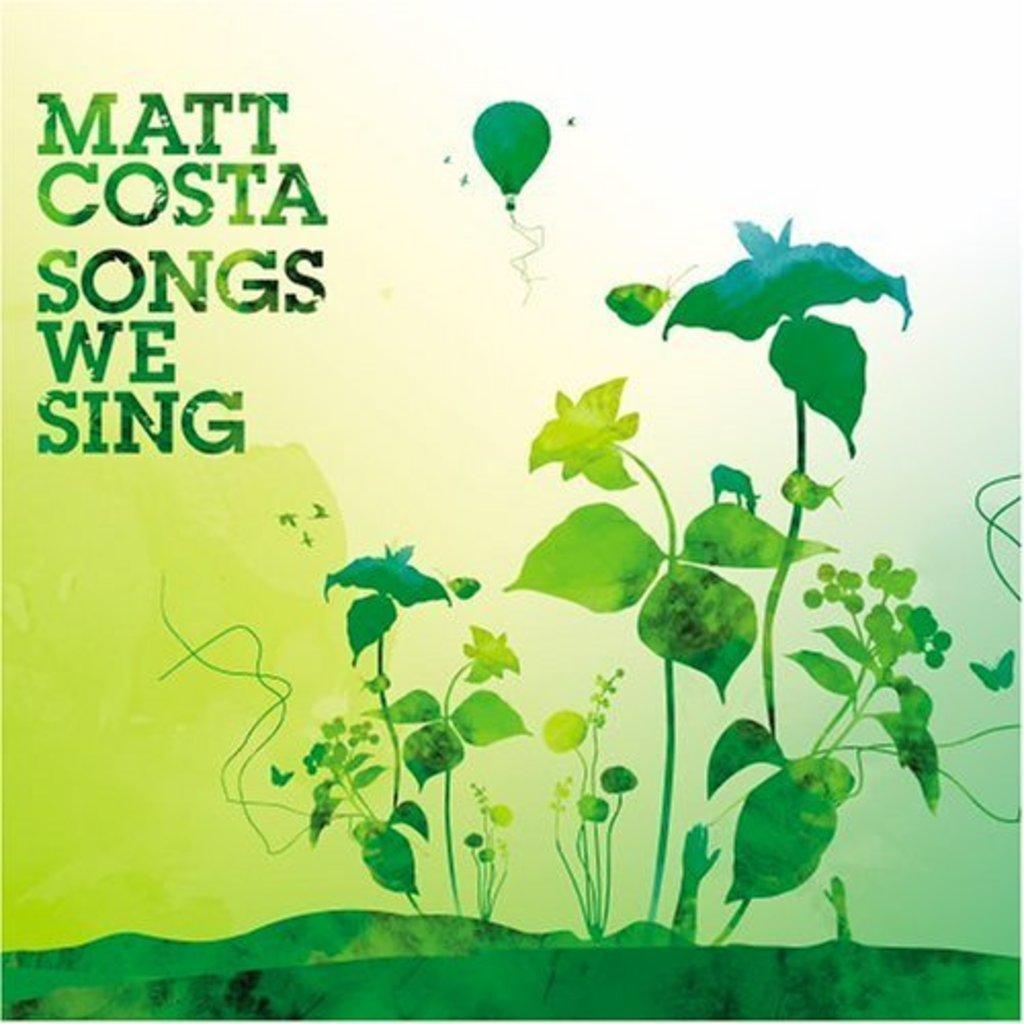Please provide a concise description of this image. In this picture we can see poster, in this poster we can see plants, paragliding, grass and text. 